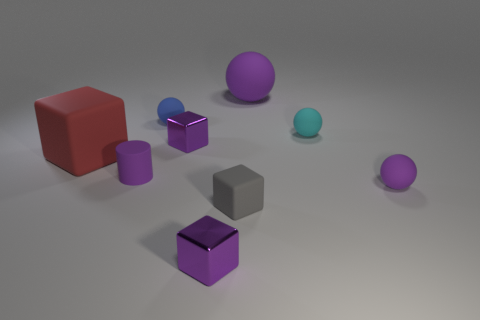Subtract all tiny cubes. How many cubes are left? 1 Subtract all red blocks. How many blocks are left? 3 Subtract 1 cylinders. How many cylinders are left? 0 Subtract all green blocks. How many green cylinders are left? 0 Subtract all spheres. How many objects are left? 5 Subtract all brown balls. Subtract all yellow blocks. How many balls are left? 4 Subtract all cyan rubber balls. Subtract all tiny gray things. How many objects are left? 7 Add 4 gray matte objects. How many gray matte objects are left? 5 Add 7 tiny blue matte things. How many tiny blue matte things exist? 8 Subtract 0 blue cubes. How many objects are left? 9 